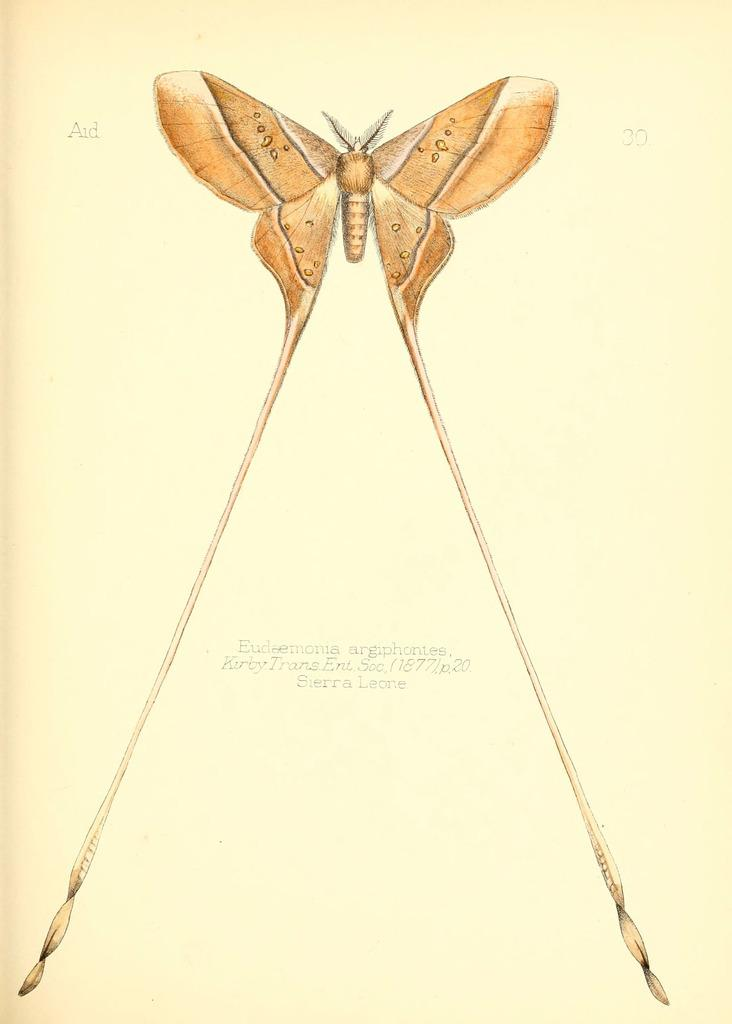What is depicted in the image? There is a picture of a butterfly in the image. What is the picture of the butterfly printed on? The picture of the butterfly is on a paper. What type of wilderness can be seen in the background of the butterfly picture? There is no background or wilderness visible in the image, as it only features a picture of a butterfly on a paper. 